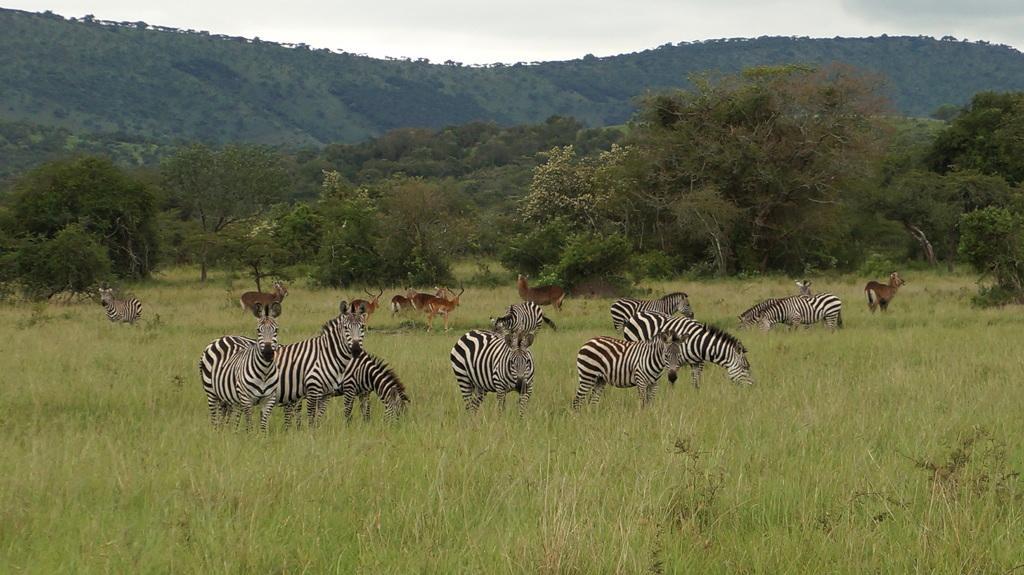In one or two sentences, can you explain what this image depicts? This picture might be taken in a forest, in this picture in the center there are a group of zebras and deers. At the bottom there is grass and some plants, in the background there are some mountains and trees. On the top of the image there is sky. 